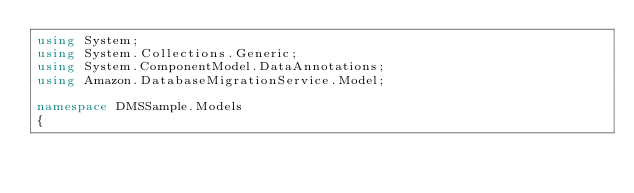<code> <loc_0><loc_0><loc_500><loc_500><_C#_>using System;
using System.Collections.Generic;
using System.ComponentModel.DataAnnotations;
using Amazon.DatabaseMigrationService.Model;

namespace DMSSample.Models
{</code> 